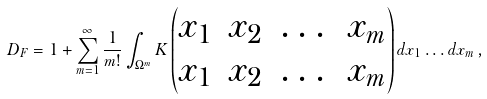Convert formula to latex. <formula><loc_0><loc_0><loc_500><loc_500>D _ { F } = 1 + \sum _ { m = 1 } ^ { \infty } \frac { 1 } { m ! } \int _ { \Omega ^ { m } } K \begin{pmatrix} x _ { 1 } & x _ { 2 } & \dots & x _ { m } \\ x _ { 1 } & x _ { 2 } & \dots & x _ { m } \end{pmatrix} d x _ { 1 } \dots d x _ { m } \, ,</formula> 